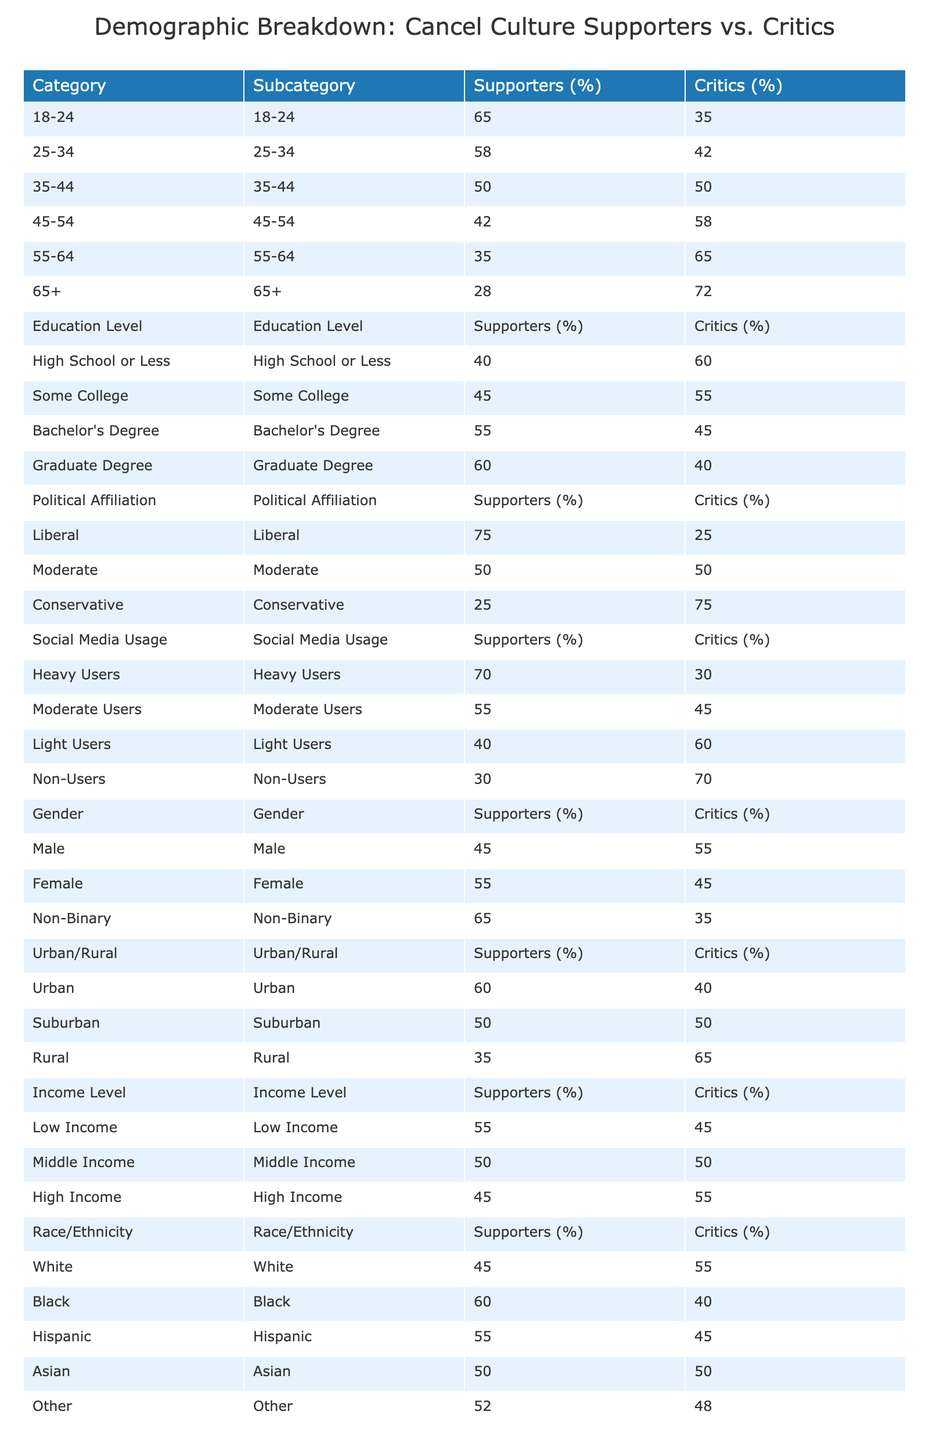What percentage of 18-24 age group supports cancel culture? According to the table, the supporters in the 18-24 age group are noted as 65%.
Answer: 65% In which income level category is support for cancel culture lowest? By looking at the income level section, the high-income group's support is 45%, which is the lowest compared to other income levels.
Answer: High Income What is the difference in support for cancel culture between heavy social media users and light users? Heavy users support cancel culture at 70%, while light users have support at 40%. The difference is calculated as 70 - 40 = 30%.
Answer: 30% Is there a higher percentage of critics among males or females? Males have a 55% critic rate while females have 45%. Since 55% (males) is greater than 45% (females), it shows that there is a higher percentage of critics among males.
Answer: Yes What is the average percentage of supporters across all racial/ethnic groups listed? To find the average, sum the percentages of supporters across all groups: (45 + 60 + 55 + 50 + 52) = 262. There are 5 groups, so the average is 262/5 = 52.4%.
Answer: 52.4% 